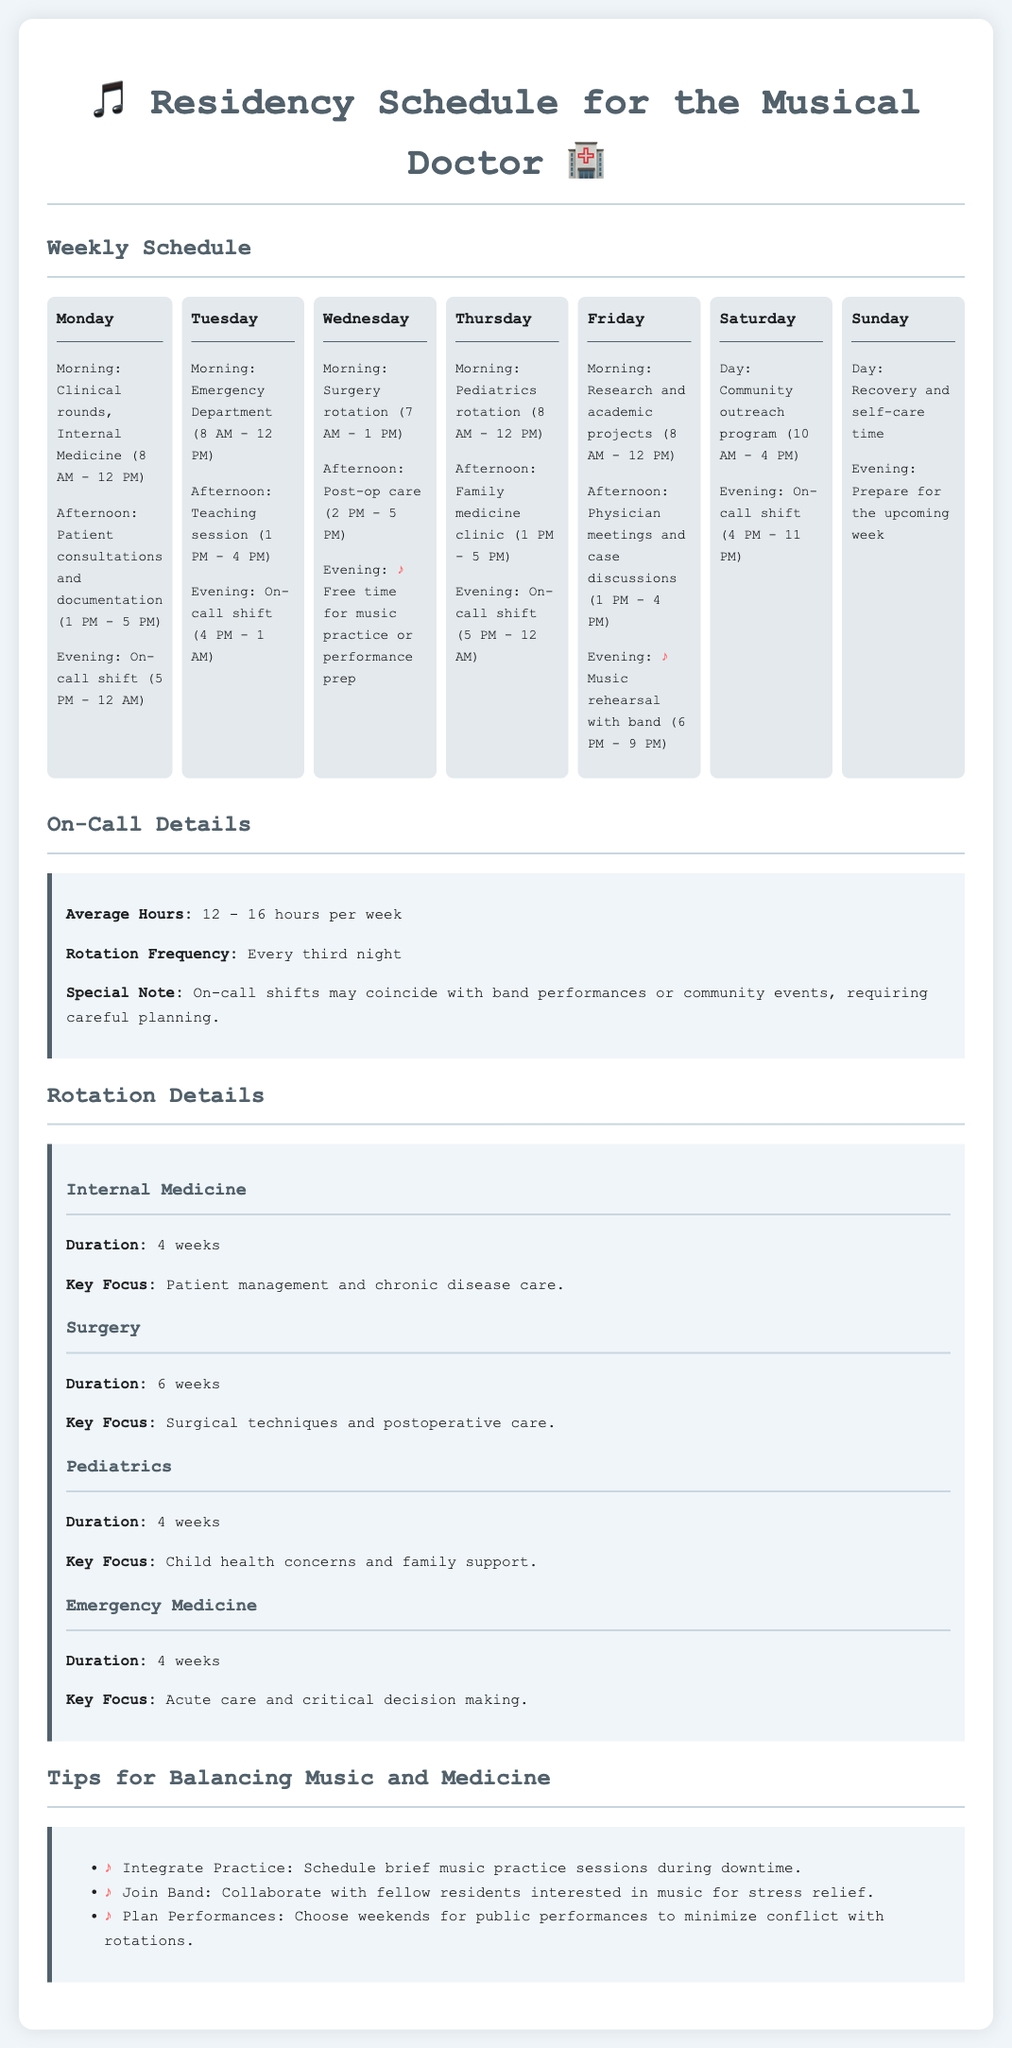What is the duration of the Internal Medicine rotation? The duration for the Internal Medicine rotation is specified in the document.
Answer: 4 weeks How many weekly on-call hours are there on average? The document provides information on the average number of hours for on-call shifts each week.
Answer: 12 - 16 hours What day is the Music rehearsal scheduled? The document lists the activities for each day and specifies the day for music rehearsal.
Answer: Friday What is the key focus of the Surgery rotation? Each rotation in the document outlines key focus areas, including that of Surgery.
Answer: Surgical techniques and postoperative care On which day is the Emergency Department shift scheduled? The schedule details the specific day dedicated to the Emergency Department.
Answer: Tuesday What time does the Pediatrics rotation end? The document specifies the start and end times for the Pediatrics rotation.
Answer: 12 PM How often do on-call shifts occur? The document states the frequency of on-call shifts during the residency schedule.
Answer: Every third night Which day is dedicated to post-operative care? The schedule logically organizes the activities of each day, including post-operative care.
Answer: Wednesday What is the evening activity on Sunday? The document outlines the activities planned for each evening, including Sunday.
Answer: Prepare for the upcoming week 